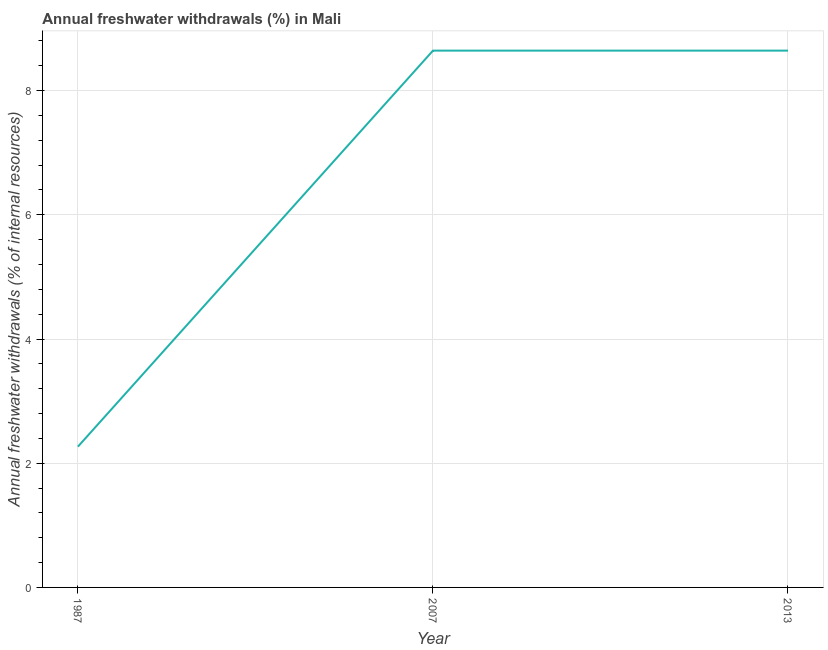What is the annual freshwater withdrawals in 2013?
Ensure brevity in your answer.  8.64. Across all years, what is the maximum annual freshwater withdrawals?
Keep it short and to the point. 8.64. Across all years, what is the minimum annual freshwater withdrawals?
Provide a short and direct response. 2.27. In which year was the annual freshwater withdrawals minimum?
Make the answer very short. 1987. What is the sum of the annual freshwater withdrawals?
Make the answer very short. 19.55. What is the difference between the annual freshwater withdrawals in 1987 and 2013?
Your answer should be very brief. -6.38. What is the average annual freshwater withdrawals per year?
Ensure brevity in your answer.  6.52. What is the median annual freshwater withdrawals?
Provide a succinct answer. 8.64. What is the ratio of the annual freshwater withdrawals in 1987 to that in 2007?
Offer a very short reply. 0.26. Is the annual freshwater withdrawals in 1987 less than that in 2007?
Make the answer very short. Yes. What is the difference between the highest and the second highest annual freshwater withdrawals?
Offer a very short reply. 0. Is the sum of the annual freshwater withdrawals in 1987 and 2013 greater than the maximum annual freshwater withdrawals across all years?
Provide a succinct answer. Yes. What is the difference between the highest and the lowest annual freshwater withdrawals?
Make the answer very short. 6.38. In how many years, is the annual freshwater withdrawals greater than the average annual freshwater withdrawals taken over all years?
Ensure brevity in your answer.  2. How many lines are there?
Your response must be concise. 1. How many years are there in the graph?
Make the answer very short. 3. Are the values on the major ticks of Y-axis written in scientific E-notation?
Provide a succinct answer. No. Does the graph contain grids?
Your answer should be compact. Yes. What is the title of the graph?
Your answer should be compact. Annual freshwater withdrawals (%) in Mali. What is the label or title of the Y-axis?
Make the answer very short. Annual freshwater withdrawals (% of internal resources). What is the Annual freshwater withdrawals (% of internal resources) in 1987?
Provide a succinct answer. 2.27. What is the Annual freshwater withdrawals (% of internal resources) in 2007?
Offer a terse response. 8.64. What is the Annual freshwater withdrawals (% of internal resources) of 2013?
Your answer should be compact. 8.64. What is the difference between the Annual freshwater withdrawals (% of internal resources) in 1987 and 2007?
Give a very brief answer. -6.38. What is the difference between the Annual freshwater withdrawals (% of internal resources) in 1987 and 2013?
Keep it short and to the point. -6.38. What is the difference between the Annual freshwater withdrawals (% of internal resources) in 2007 and 2013?
Ensure brevity in your answer.  0. What is the ratio of the Annual freshwater withdrawals (% of internal resources) in 1987 to that in 2007?
Make the answer very short. 0.26. What is the ratio of the Annual freshwater withdrawals (% of internal resources) in 1987 to that in 2013?
Your answer should be very brief. 0.26. What is the ratio of the Annual freshwater withdrawals (% of internal resources) in 2007 to that in 2013?
Provide a succinct answer. 1. 